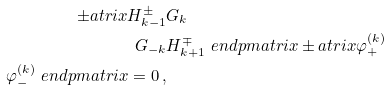Convert formula to latex. <formula><loc_0><loc_0><loc_500><loc_500>\pm a t r i x H _ { k - 1 } ^ { \pm } & G _ { k } \\ G _ { - k } & H _ { k + 1 } ^ { \mp } \ e n d p m a t r i x \pm a t r i x \varphi _ { + } ^ { ( k ) } \\ \varphi _ { - } ^ { ( k ) } \ e n d p m a t r i x = 0 \, ,</formula> 